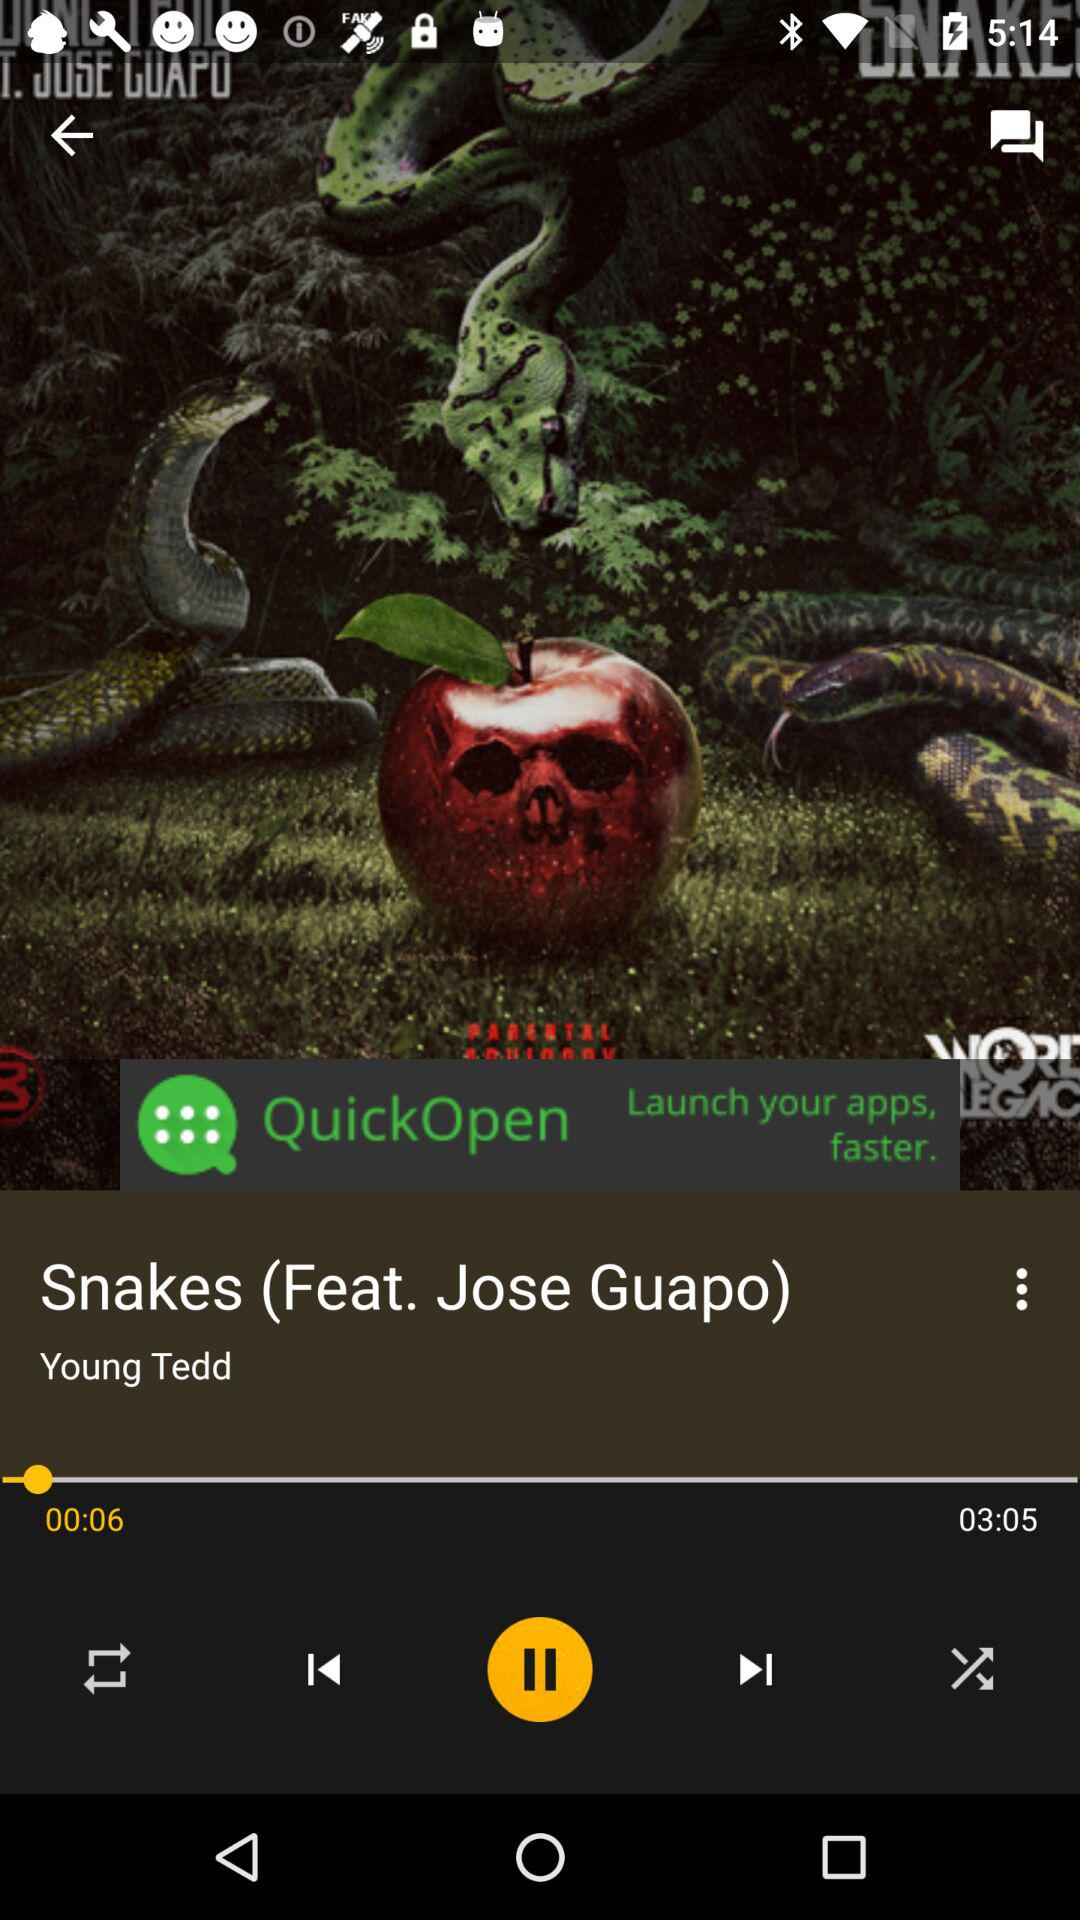Who is the singer of the song? The singer of the song is Young Tedd. 